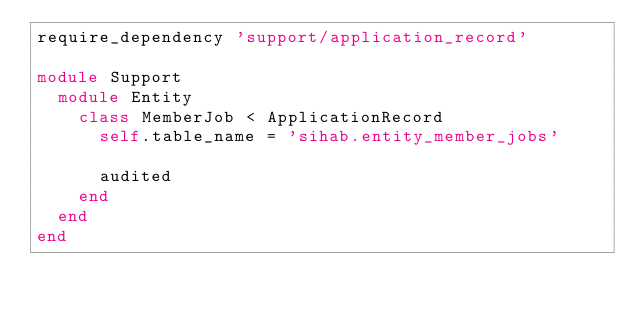Convert code to text. <code><loc_0><loc_0><loc_500><loc_500><_Ruby_>require_dependency 'support/application_record'

module Support
  module Entity
    class MemberJob < ApplicationRecord
      self.table_name = 'sihab.entity_member_jobs'

      audited
    end
  end
end
</code> 